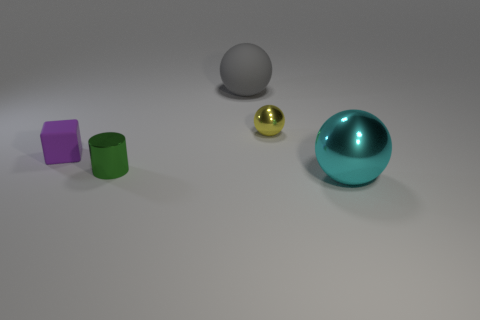Are there any big cyan spheres that are in front of the metal ball that is in front of the tiny purple matte object?
Offer a terse response. No. There is a yellow thing that is the same material as the cylinder; what is its shape?
Offer a terse response. Sphere. Is there any other thing that is the same color as the tiny metal sphere?
Give a very brief answer. No. What is the material of the gray thing that is the same shape as the large cyan thing?
Your response must be concise. Rubber. What number of other things are the same size as the cyan ball?
Ensure brevity in your answer.  1. There is a matte object to the right of the green metallic thing; is its shape the same as the small yellow object?
Provide a succinct answer. Yes. How many other objects are there of the same shape as the large gray thing?
Offer a terse response. 2. There is a big thing behind the tiny cylinder; what shape is it?
Give a very brief answer. Sphere. Are there any green cylinders made of the same material as the cyan object?
Your response must be concise. Yes. Does the large object in front of the tiny green object have the same color as the tiny cylinder?
Offer a very short reply. No. 